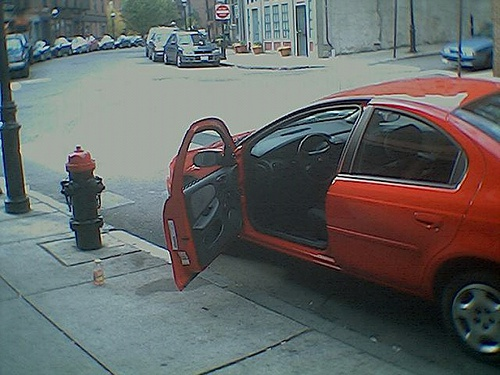Describe the objects in this image and their specific colors. I can see car in darkblue, black, maroon, brown, and gray tones, fire hydrant in darkblue, black, gray, and navy tones, car in darkblue, gray, black, and darkgray tones, car in darkblue, gray, blue, black, and teal tones, and car in darkblue, teal, black, blue, and darkgray tones in this image. 